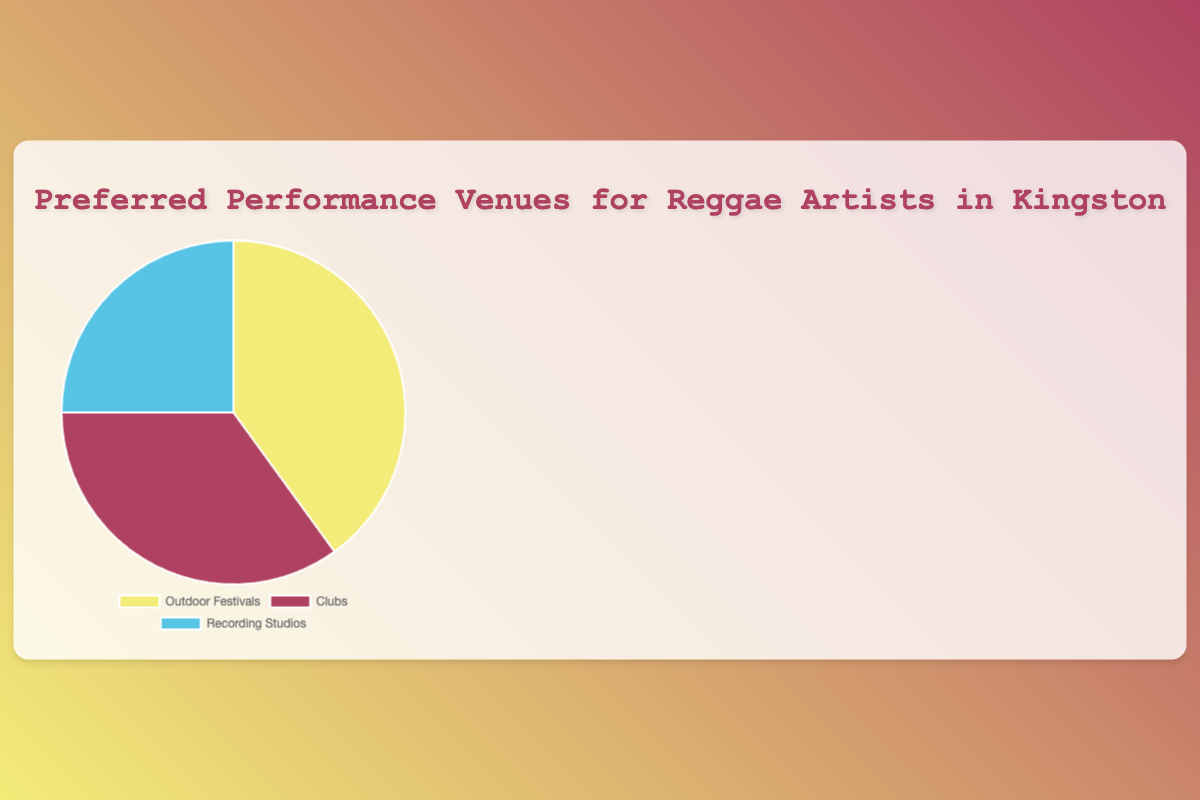What is the most preferred performance venue among reggae artists in Kingston? According to the chart, the segment with the largest percentage is Outdoor Festivals, which accounts for 40% of preferences.
Answer: Outdoor Festivals Which performance venue is preferred by the smallest percentage of reggae artists in Kingston? The chart shows that Recording Studios have the smallest segment, which constitutes 25% of the preferences.
Answer: Recording Studios By how many percentage points do reggae artists prefer Outdoor Festivals over Recording Studios? Outdoor Festivals are preferred by 40%, while Recording Studios are preferred by 25%. The difference is 40% - 25% = 15%.
Answer: 15% What is the combined percentage of reggae artists who prefer performing at Clubs and Recording Studios? Clubs are preferred by 35% and Recording Studios by 25%. Adding these together gives 35% + 25% = 60%.
Answer: 60% Which two performance venues combined have a higher preference than Outdoor Festivals alone? The preference for Outdoor Festivals is 40%. The combined preference for Clubs and Recording Studios is 35% + 25% = 60%, which is higher than 40%.
Answer: Clubs and Recording Studios Which segment is represented by the blue color in the chart? The chart uses blue to represent the percentage of reggae artists who prefer Recording Studios for their performance venues.
Answer: Recording Studios If you combine the percentages for Outdoor Festivals and Clubs, how much more is it compared to Recording Studios? The combined percentage for Outdoor Festivals and Clubs is 40% + 35% = 75%. The difference between this combined percentage and Recording Studios' 25% is 75% - 25% = 50%.
Answer: 50% Rank the performance venues from most to least preferred. The segment percentages indicate the order is Outdoor Festivals (40%), followed by Clubs (35%), and then Recording Studios (25%).
Answer: Outdoor Festivals, Clubs, Recording Studios 